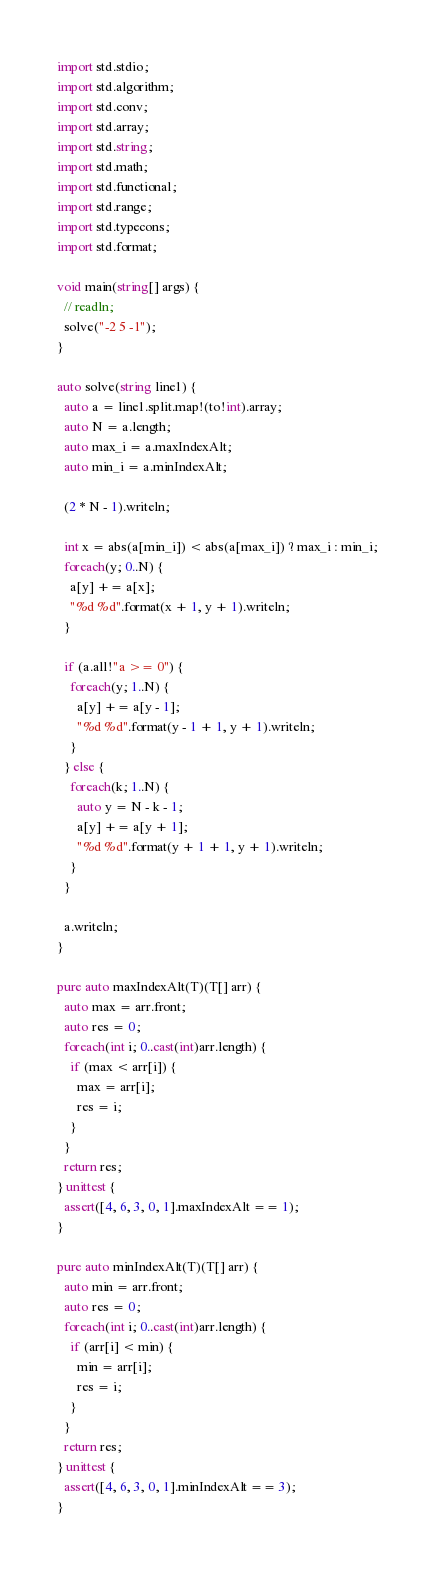Convert code to text. <code><loc_0><loc_0><loc_500><loc_500><_D_>import std.stdio;
import std.algorithm;
import std.conv;
import std.array;
import std.string;
import std.math;
import std.functional;
import std.range;
import std.typecons;
import std.format;

void main(string[] args) {
  // readln;
  solve("-2 5 -1");
}

auto solve(string line1) {
  auto a = line1.split.map!(to!int).array;
  auto N = a.length;
  auto max_i = a.maxIndexAlt;
  auto min_i = a.minIndexAlt;
  
  (2 * N - 1).writeln;
  
  int x = abs(a[min_i]) < abs(a[max_i]) ? max_i : min_i;
  foreach(y; 0..N) {
    a[y] += a[x];
    "%d %d".format(x + 1, y + 1).writeln;
  }

  if (a.all!"a >= 0") {
    foreach(y; 1..N) {
      a[y] += a[y - 1];
      "%d %d".format(y - 1 + 1, y + 1).writeln;
    }
  } else {
    foreach(k; 1..N) {
      auto y = N - k - 1;
      a[y] += a[y + 1];
      "%d %d".format(y + 1 + 1, y + 1).writeln;
    }
  }

  a.writeln;
}

pure auto maxIndexAlt(T)(T[] arr) {
  auto max = arr.front;
  auto res = 0;
  foreach(int i; 0..cast(int)arr.length) {
    if (max < arr[i]) {
      max = arr[i];
      res = i;
    }
  }
  return res;
} unittest {
  assert([4, 6, 3, 0, 1].maxIndexAlt == 1);
}

pure auto minIndexAlt(T)(T[] arr) {
  auto min = arr.front;
  auto res = 0;
  foreach(int i; 0..cast(int)arr.length) {
    if (arr[i] < min) {
      min = arr[i];
      res = i;
    }
  }
  return res;
} unittest {
  assert([4, 6, 3, 0, 1].minIndexAlt == 3);
}
</code> 